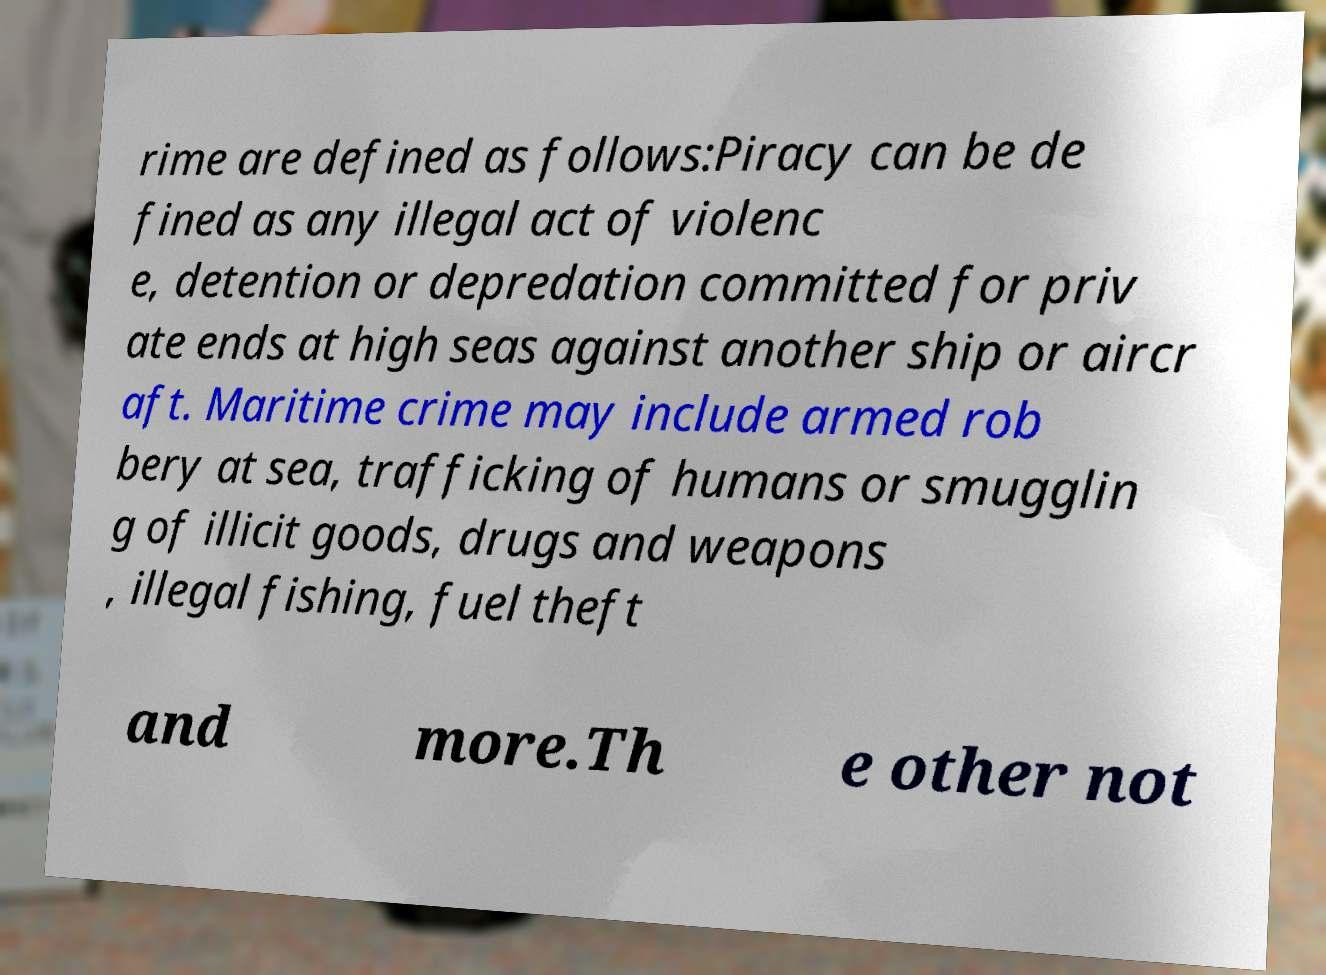For documentation purposes, I need the text within this image transcribed. Could you provide that? rime are defined as follows:Piracy can be de fined as any illegal act of violenc e, detention or depredation committed for priv ate ends at high seas against another ship or aircr aft. Maritime crime may include armed rob bery at sea, trafficking of humans or smugglin g of illicit goods, drugs and weapons , illegal fishing, fuel theft and more.Th e other not 